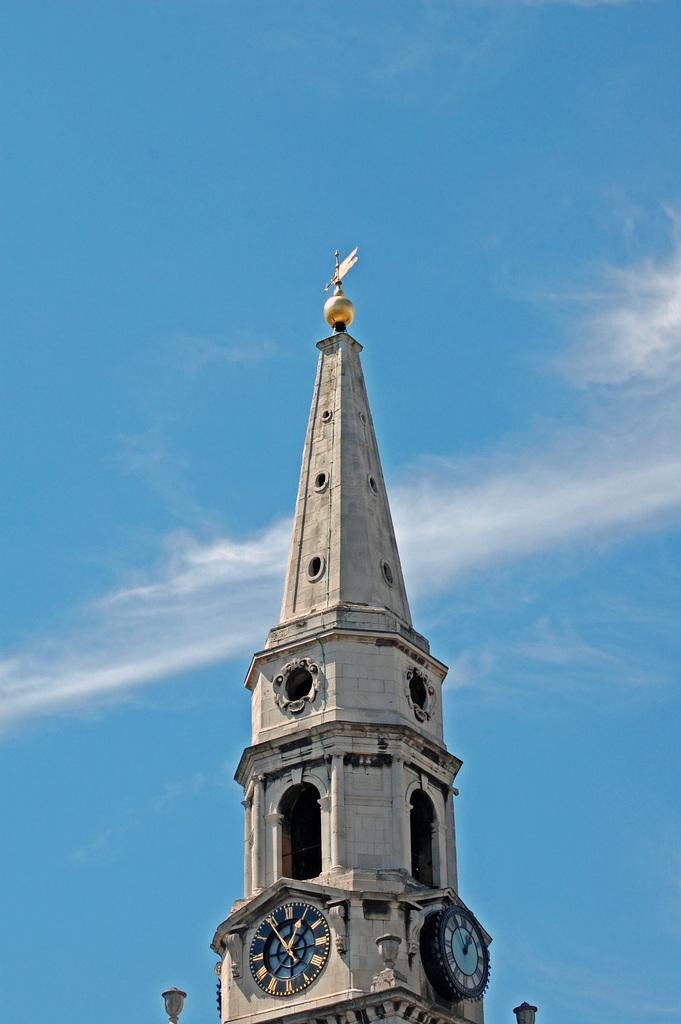What is the main structure in the middle of the image? There is a clock tower in the middle of the image. What can be seen on either side of the clock tower? There are lights on either side of the clock tower. What is visible in the background of the image? The sky is visible in the background of the image. What is the color of the sky in the image? The color of the sky is blue. How many steps are there leading up to the jail in the image? There is no jail present in the image, so it is not possible to determine the number of steps leading up to it. 